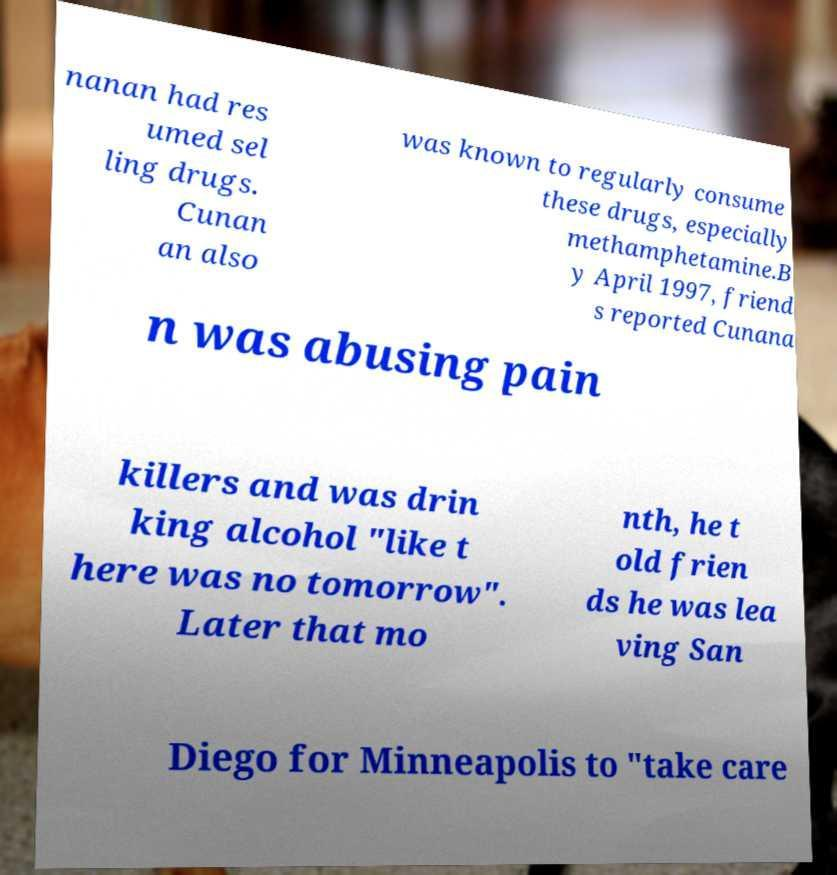Please read and relay the text visible in this image. What does it say? nanan had res umed sel ling drugs. Cunan an also was known to regularly consume these drugs, especially methamphetamine.B y April 1997, friend s reported Cunana n was abusing pain killers and was drin king alcohol "like t here was no tomorrow". Later that mo nth, he t old frien ds he was lea ving San Diego for Minneapolis to "take care 